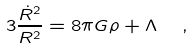Convert formula to latex. <formula><loc_0><loc_0><loc_500><loc_500>3 \frac { \dot { R } ^ { 2 } } { R ^ { 2 } } = 8 \pi G \rho + \Lambda \ \ ,</formula> 